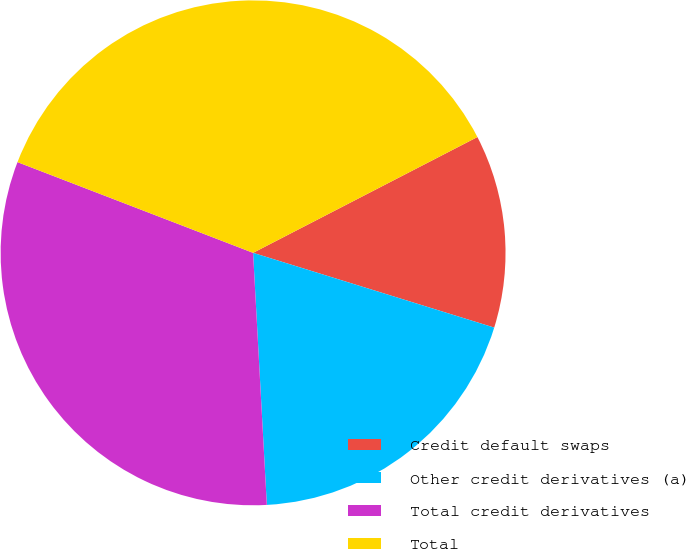Convert chart. <chart><loc_0><loc_0><loc_500><loc_500><pie_chart><fcel>Credit default swaps<fcel>Other credit derivatives (a)<fcel>Total credit derivatives<fcel>Total<nl><fcel>12.37%<fcel>19.35%<fcel>31.72%<fcel>36.57%<nl></chart> 